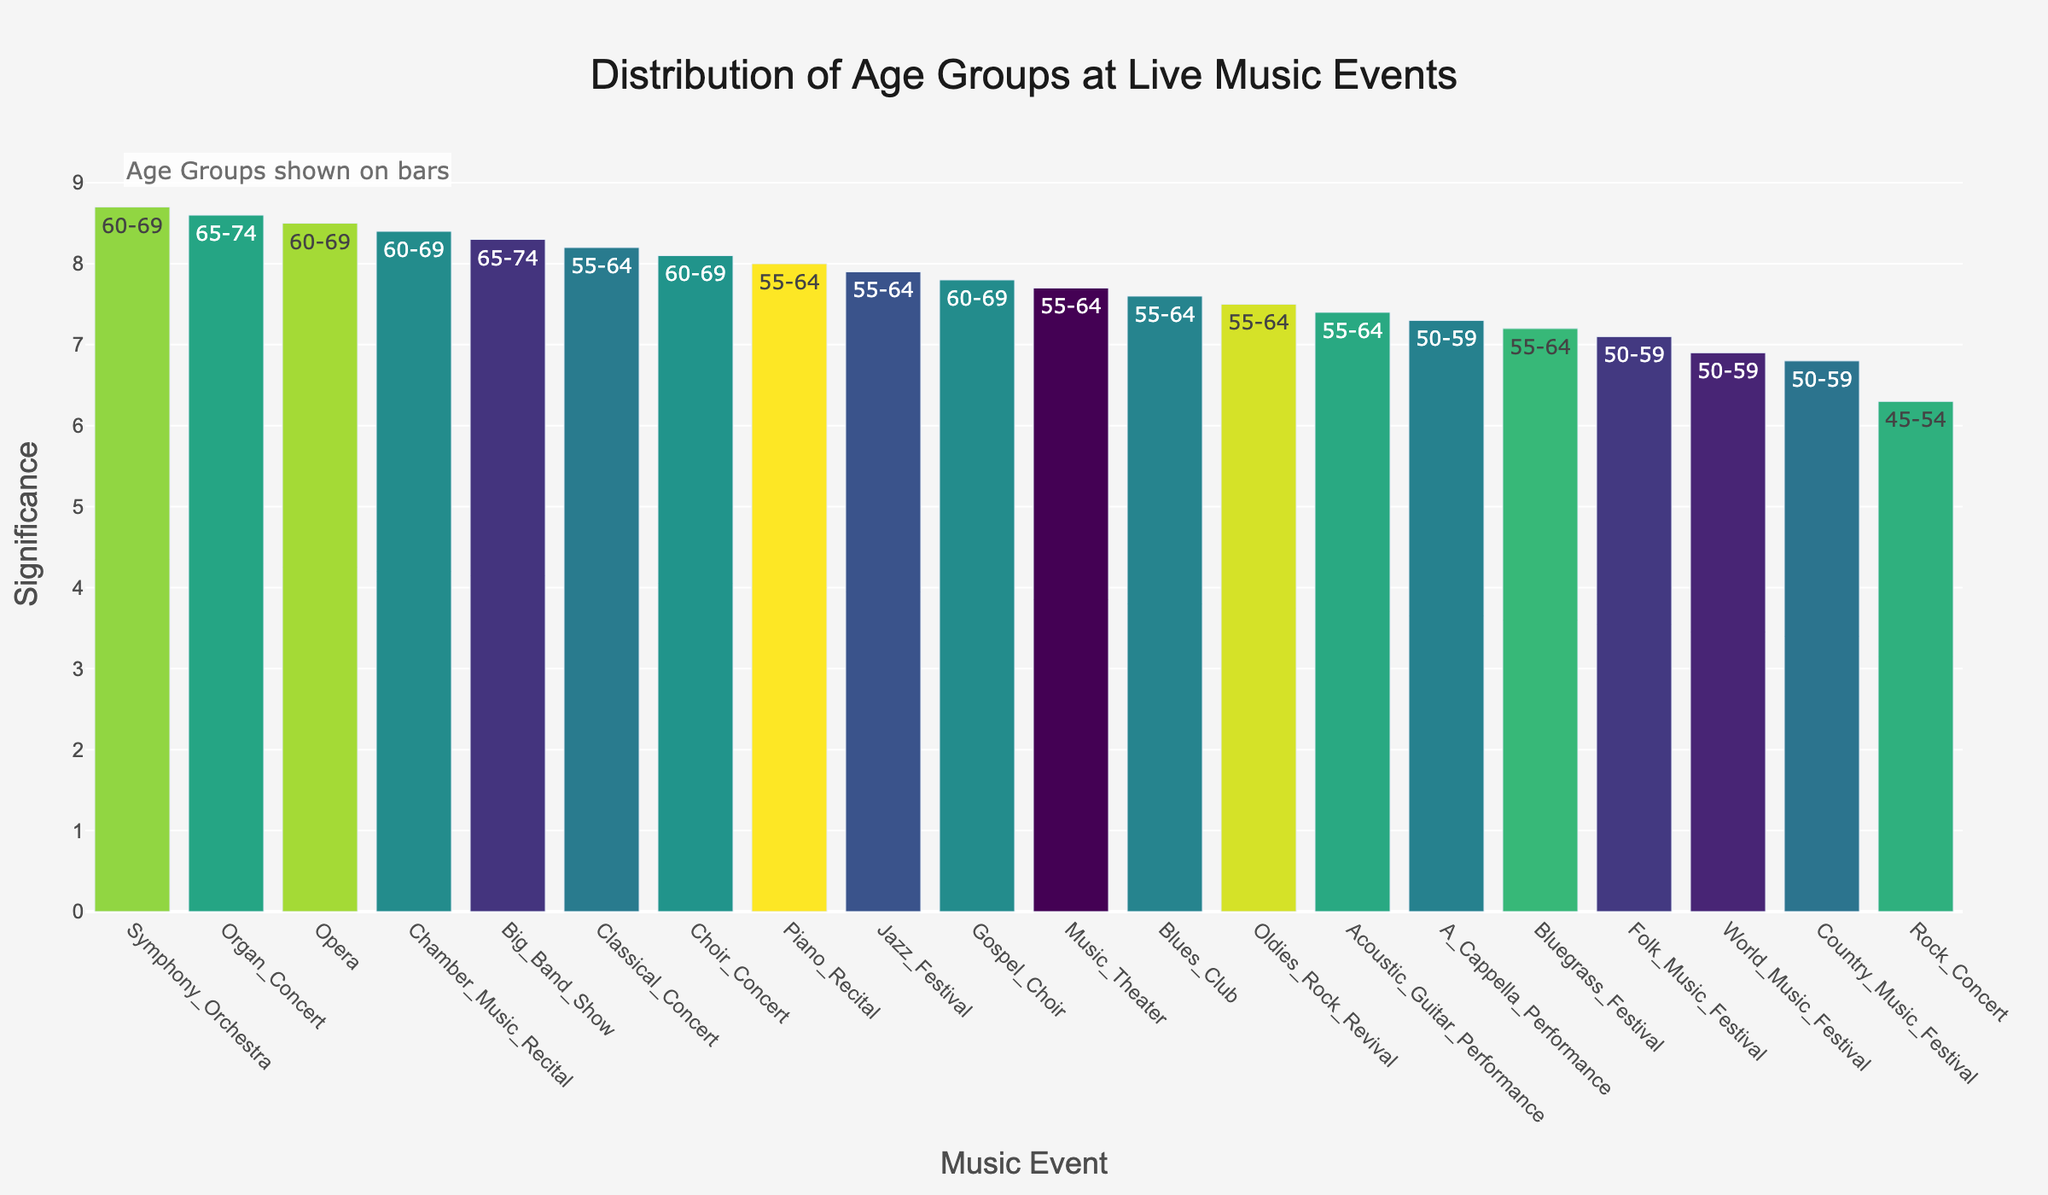what is the title of the plot? The plot's title is usually located at the top center of the figure. The title in this plot is "Distribution of Age Groups at Live Music Events," indicating the overall theme and data focus.
Answer: Distribution of Age Groups at Live Music Events Which age group attended the Symphony Orchestra event? The age group information is displayed as text on top of the bars representing each event. Look for the "Symphony Orchestra" event and read the corresponding text on its bar.
Answer: 60-69 How many events have a significance score of 8.0 or higher? Identify and count the bars that reach or exceed the 8.0 mark on the y-axis of the plot.
Answer: 9 Which event has the highest significance score? Observe the y-axis for the highest value and the corresponding bar to find the event with the highest significance. The highest bar represents the "Symphony Orchestra" with a significance score of 8.7.
Answer: Symphony Orchestra What is the average significance score across all events? Sum all the significance scores for each event and divide by the total number of events. The significance scores are: 8.2, 7.9, 8.5, 6.3, 7.1, 7.6, 8.7, 6.8, 7.4, 8.1, 8.3, 7.7, 8.4, 7.5, 6.9, 7.8, 8.0, 7.2, 7.3, 8.6. (8.2+7.9+8.5+6.3+7.1+7.6+8.7+6.8+7.4+8.1+8.3+7.7+8.4+7.5+6.9+7.8+8.0+7.2+7.3+8.6)/20 = 7.75
Answer: 7.75 Which age group prefers Rock Concerts compared to Opera? Check the text above the bars for "Rock Concert" and "Opera" to identify the age groups. "Rock Concert" is attended by the 45-54 age group, and "Opera" is attended by the 60-69 age group. Compare these groups directly.
Answer: 45-54 and 60-69 